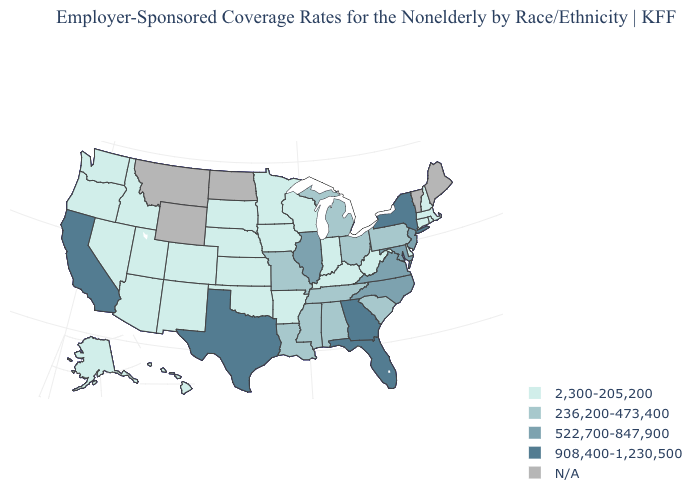Does Idaho have the lowest value in the USA?
Answer briefly. Yes. Name the states that have a value in the range N/A?
Concise answer only. Maine, Montana, North Dakota, Vermont, Wyoming. Name the states that have a value in the range 522,700-847,900?
Keep it brief. Illinois, Maryland, New Jersey, North Carolina, Virginia. Name the states that have a value in the range 236,200-473,400?
Quick response, please. Alabama, Louisiana, Michigan, Mississippi, Missouri, Ohio, Pennsylvania, South Carolina, Tennessee. What is the value of Missouri?
Keep it brief. 236,200-473,400. What is the value of Alabama?
Keep it brief. 236,200-473,400. Name the states that have a value in the range 908,400-1,230,500?
Write a very short answer. California, Florida, Georgia, New York, Texas. What is the value of Arizona?
Answer briefly. 2,300-205,200. Name the states that have a value in the range N/A?
Give a very brief answer. Maine, Montana, North Dakota, Vermont, Wyoming. Name the states that have a value in the range 908,400-1,230,500?
Quick response, please. California, Florida, Georgia, New York, Texas. Name the states that have a value in the range 236,200-473,400?
Quick response, please. Alabama, Louisiana, Michigan, Mississippi, Missouri, Ohio, Pennsylvania, South Carolina, Tennessee. Among the states that border Delaware , which have the lowest value?
Short answer required. Pennsylvania. Does Massachusetts have the highest value in the Northeast?
Short answer required. No. Which states have the lowest value in the Northeast?
Concise answer only. Connecticut, Massachusetts, New Hampshire, Rhode Island. What is the value of West Virginia?
Be succinct. 2,300-205,200. 